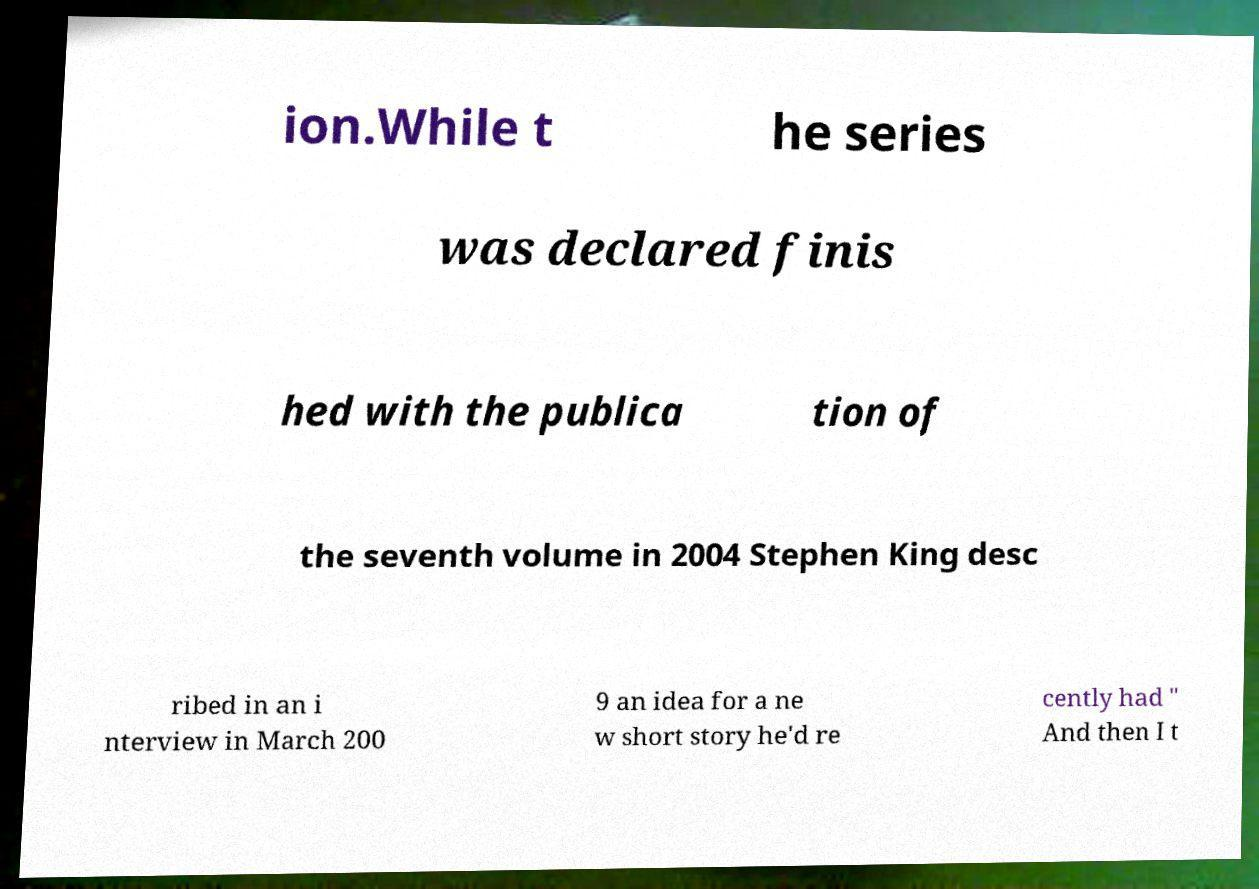Could you extract and type out the text from this image? ion.While t he series was declared finis hed with the publica tion of the seventh volume in 2004 Stephen King desc ribed in an i nterview in March 200 9 an idea for a ne w short story he'd re cently had " And then I t 